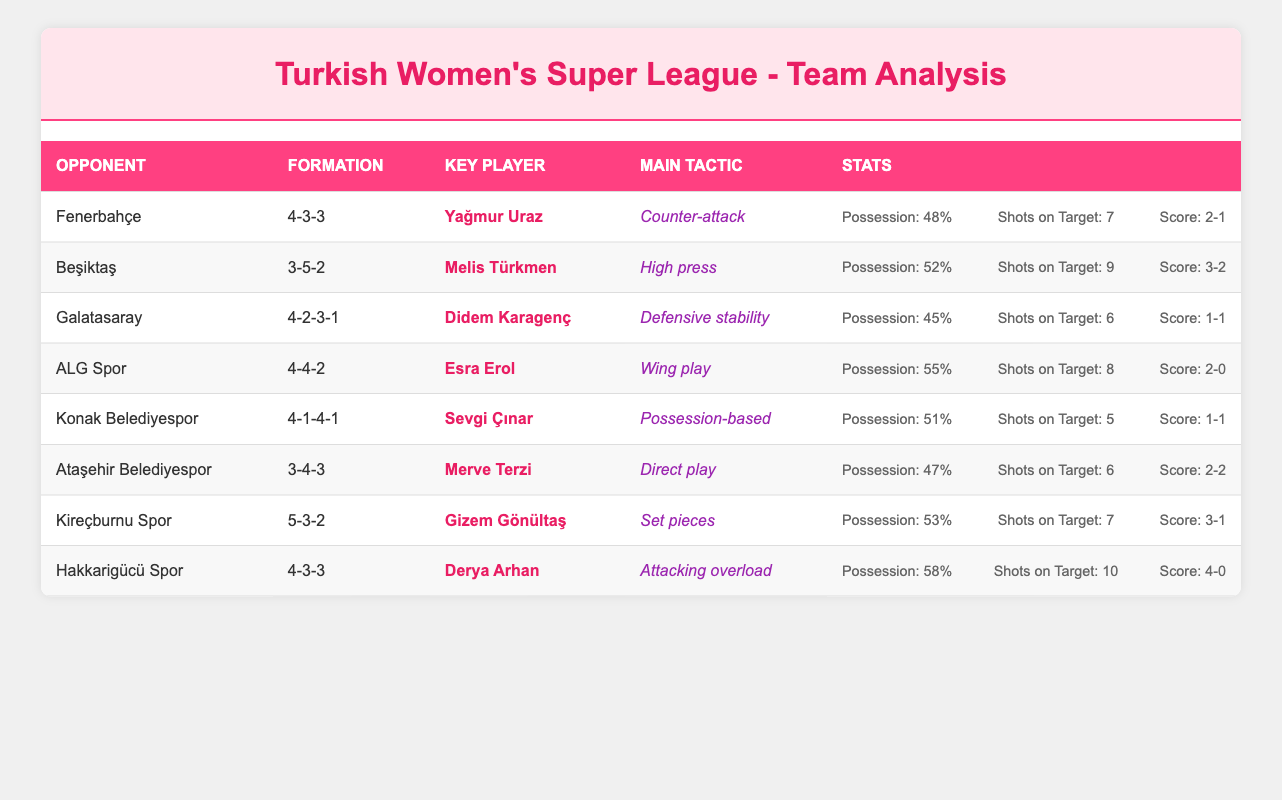What formation was used against Fenerbahçe? The table lists the opponent Fenerbahçe along with the corresponding formation in that row, which is 4-3-3.
Answer: 4-3-3 Which team had the highest possession percentage? By examining the possession percentages for all teams, Hakkarigücü Spor has the highest possession percentage at 58%.
Answer: Hakkarigücü Spor What is the score when ALG Spor played against the opponent? The score in the row corresponding to ALG Spor shows that they scored 2, and the opponent conceded 0, making the final score 2-0.
Answer: 2-0 Did any team manage to score 4 goals in a match? Looking at the goals scored column, Hakkarigücü Spor is the only team that managed to score 4 goals in a match against their opponent, which is true.
Answer: Yes What was the average number of shots on target across all matches? To find the average, we sum the shots on target (7 + 9 + 6 + 8 + 5 + 6 + 7 + 10) = 58. Since there are 8 matches, we divide 58 by 8, yielding an average of 7.25.
Answer: 7.25 Which team employed a high press tactic and what was their formation? Referring to the table, Beşiktaş used a high press tactic, and their formation listed is 3-5-2.
Answer: Beşiktaş, 3-5-2 How many goals were conceded by Kireçburnu Spor? In the row for Kireçburnu Spor, the data shows they conceded 1 goal in their match.
Answer: 1 Was it true that Galatasaray had more possession than Fenerbahçe? Galatasaray had a possession percentage of 45%, while Fenerbahçe had 48%. Thus, Galatasaray had less possession than Fenerbahçe, making the statement false.
Answer: No What is the goal difference in the match between Hakkarigücü Spor and their opponent? Hakkarigücü Spor scored 4 goals and conceded 0, so the goal difference is 4 - 0 = 4.
Answer: 4 